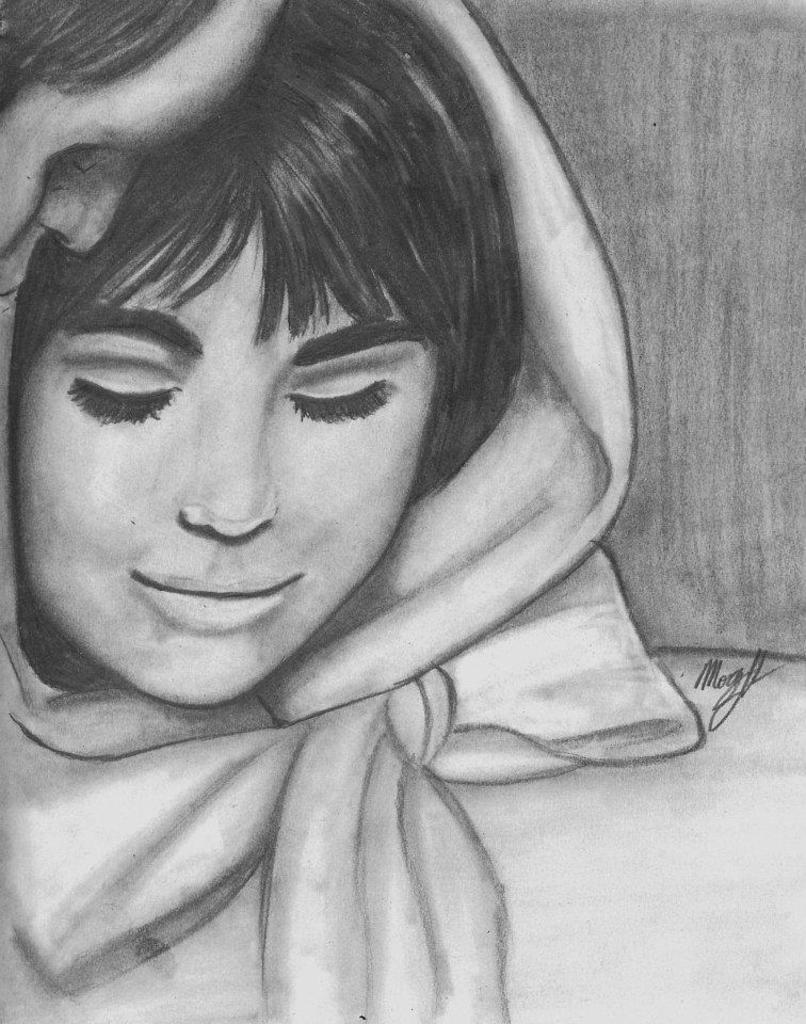What is the main subject of the image? The main subject of the image is a painting. What is depicted in the painting? The painting depicts a man and a woman. What is the income of the man depicted in the painting? The income of the man depicted in the painting cannot be determined from the image, as it is a painting and not a photograph or real-life scene. 